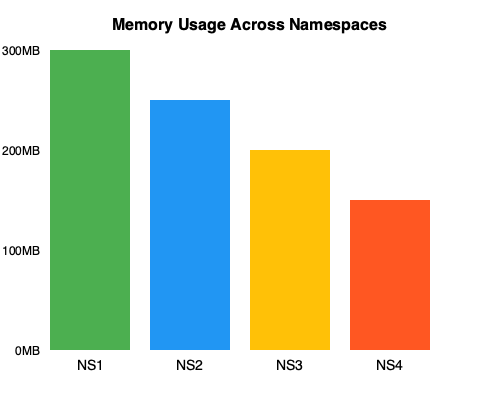Based on the bar chart showing memory usage across different namespaces (NS1, NS2, NS3, and NS4) in a large-scale software project, which optimization strategy would be most effective to reduce overall memory consumption while maintaining code organization? To determine the most effective optimization strategy, let's analyze the memory usage across namespaces:

1. NS1 (300MB): Highest memory usage
2. NS2 (250MB): Second highest memory usage
3. NS3 (200MB): Third highest memory usage
4. NS4 (150MB): Lowest memory usage

Steps to optimize memory usage:

1. Identify the namespace with the highest memory consumption (NS1).
2. Analyze the code within NS1 to find potential memory leaks or inefficient data structures.
3. Consider the following optimization techniques:
   a. Use smart pointers (e.g., std::unique_ptr, std::shared_ptr) to manage dynamic memory.
   b. Implement lazy loading for resource-intensive objects.
   c. Utilize memory pools for frequently allocated/deallocated objects.
   d. Employ move semantics to reduce unnecessary copying of large objects.
4. Refactor code in NS1 to use more memory-efficient data structures or algorithms.
5. If possible, redistribute some functionalities from NS1 to NS4 (the namespace with the lowest memory usage) to balance the memory consumption.
6. Apply similar optimization techniques to NS2 and NS3, focusing on the most memory-intensive parts of the code.
7. Implement a memory monitoring system to track usage across namespaces and identify potential issues early.
8. Regularly review and refactor code to maintain optimal memory usage.

The most effective strategy is to focus on optimizing NS1, as it has the highest memory consumption. By reducing its memory usage, we can achieve the most significant overall reduction in memory consumption while maintaining the existing namespace structure for code organization.
Answer: Optimize NS1 (highest memory usage) through refactoring, efficient data structures, and memory management techniques. 